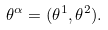Convert formula to latex. <formula><loc_0><loc_0><loc_500><loc_500>\theta ^ { \alpha } = ( \theta ^ { 1 } , \theta ^ { 2 } ) .</formula> 